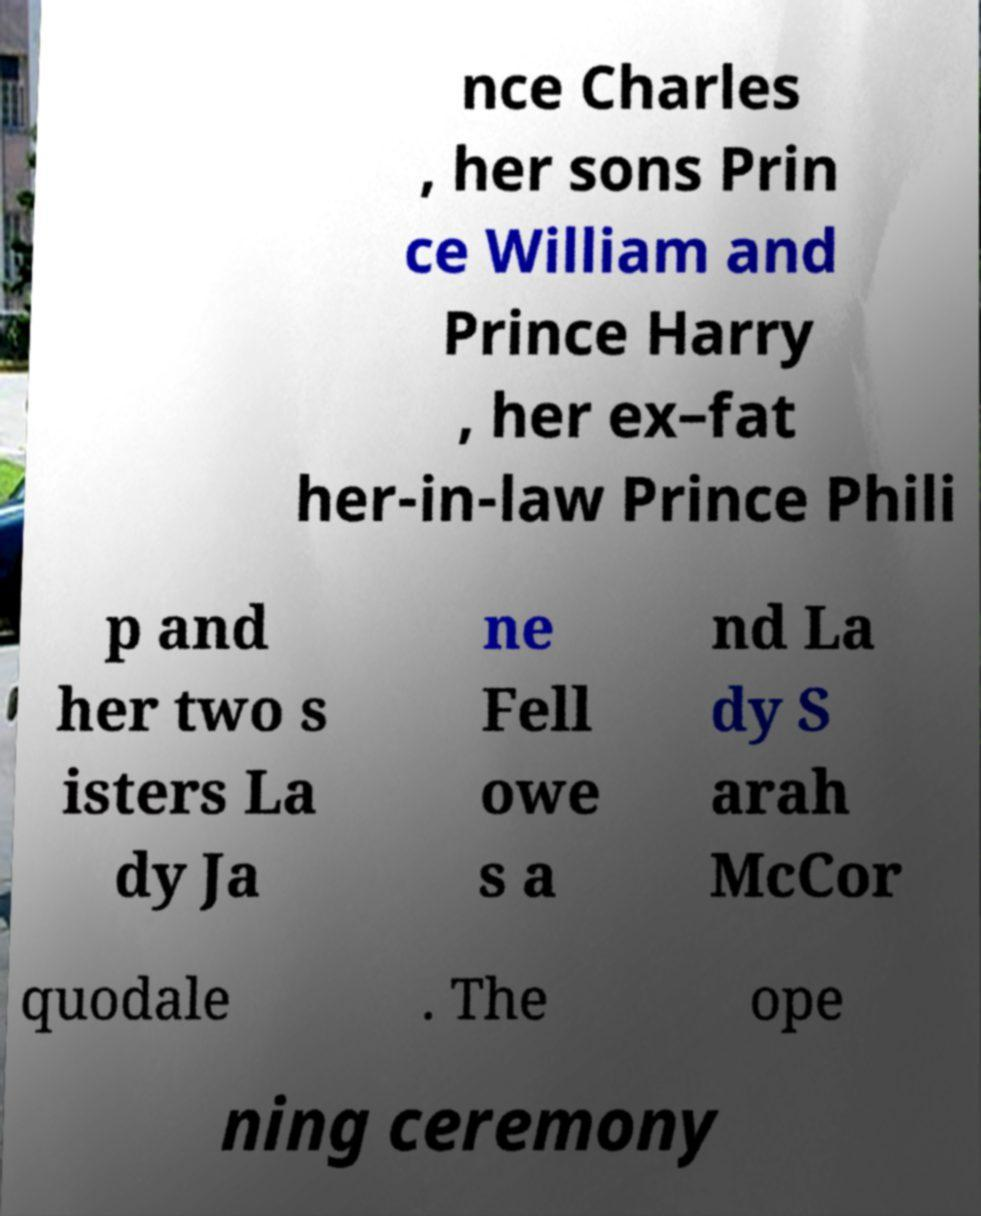For documentation purposes, I need the text within this image transcribed. Could you provide that? nce Charles , her sons Prin ce William and Prince Harry , her ex–fat her-in-law Prince Phili p and her two s isters La dy Ja ne Fell owe s a nd La dy S arah McCor quodale . The ope ning ceremony 